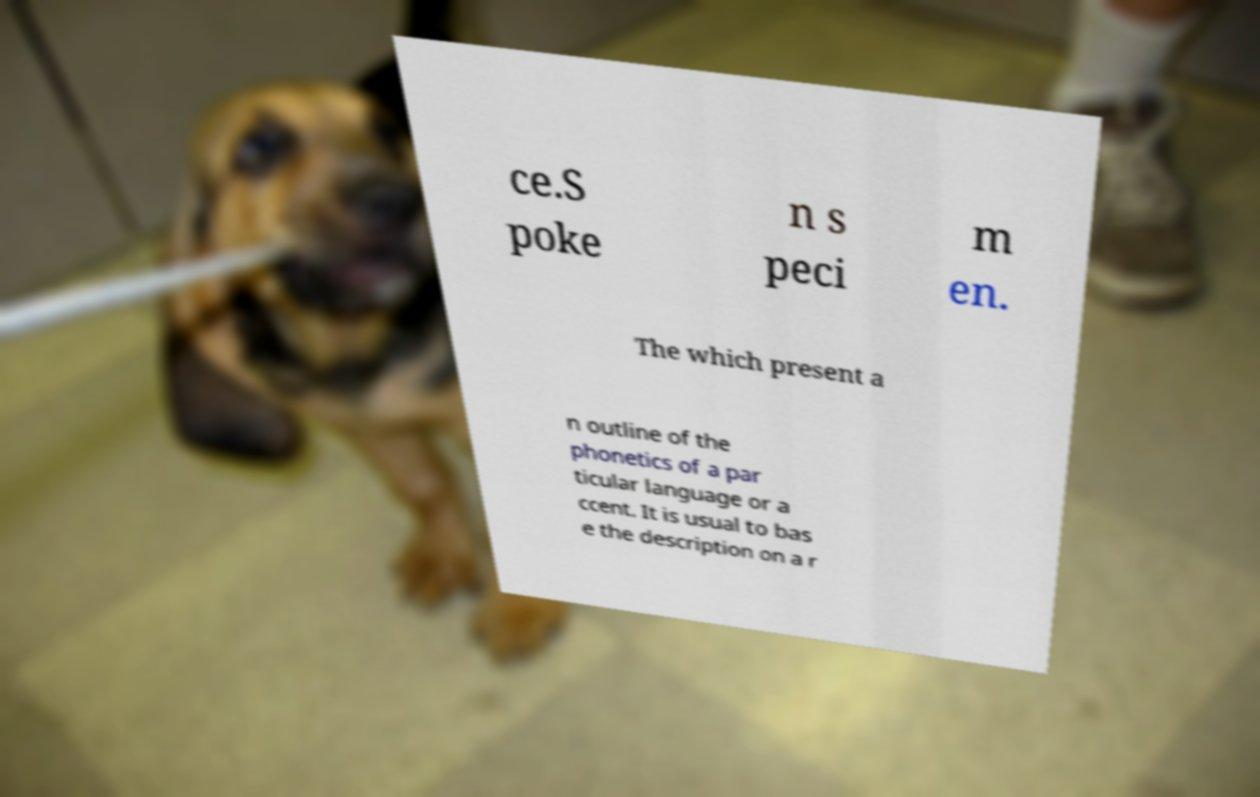Please identify and transcribe the text found in this image. ce.S poke n s peci m en. The which present a n outline of the phonetics of a par ticular language or a ccent. It is usual to bas e the description on a r 